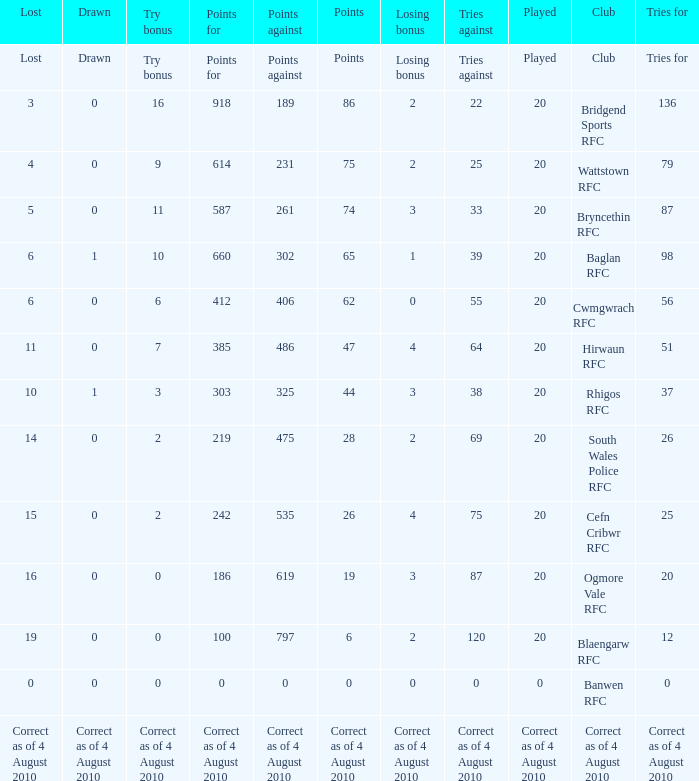What is lost when the points against is 231? 4.0. 